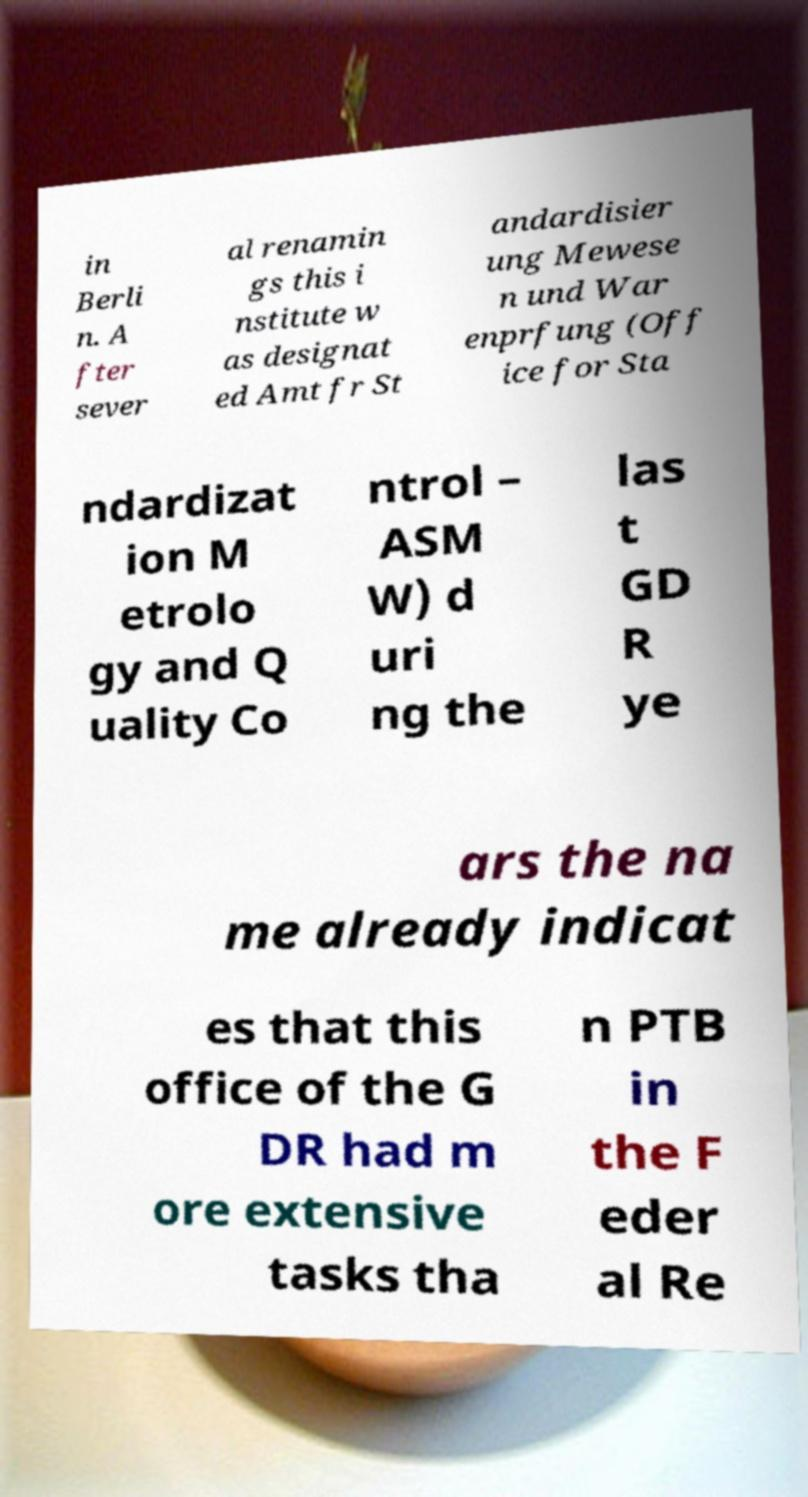What messages or text are displayed in this image? I need them in a readable, typed format. in Berli n. A fter sever al renamin gs this i nstitute w as designat ed Amt fr St andardisier ung Mewese n und War enprfung (Off ice for Sta ndardizat ion M etrolo gy and Q uality Co ntrol – ASM W) d uri ng the las t GD R ye ars the na me already indicat es that this office of the G DR had m ore extensive tasks tha n PTB in the F eder al Re 